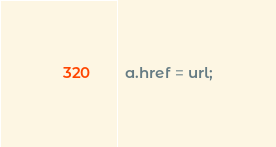Convert code to text. <code><loc_0><loc_0><loc_500><loc_500><_TypeScript_>
  a.href = url;
</code> 